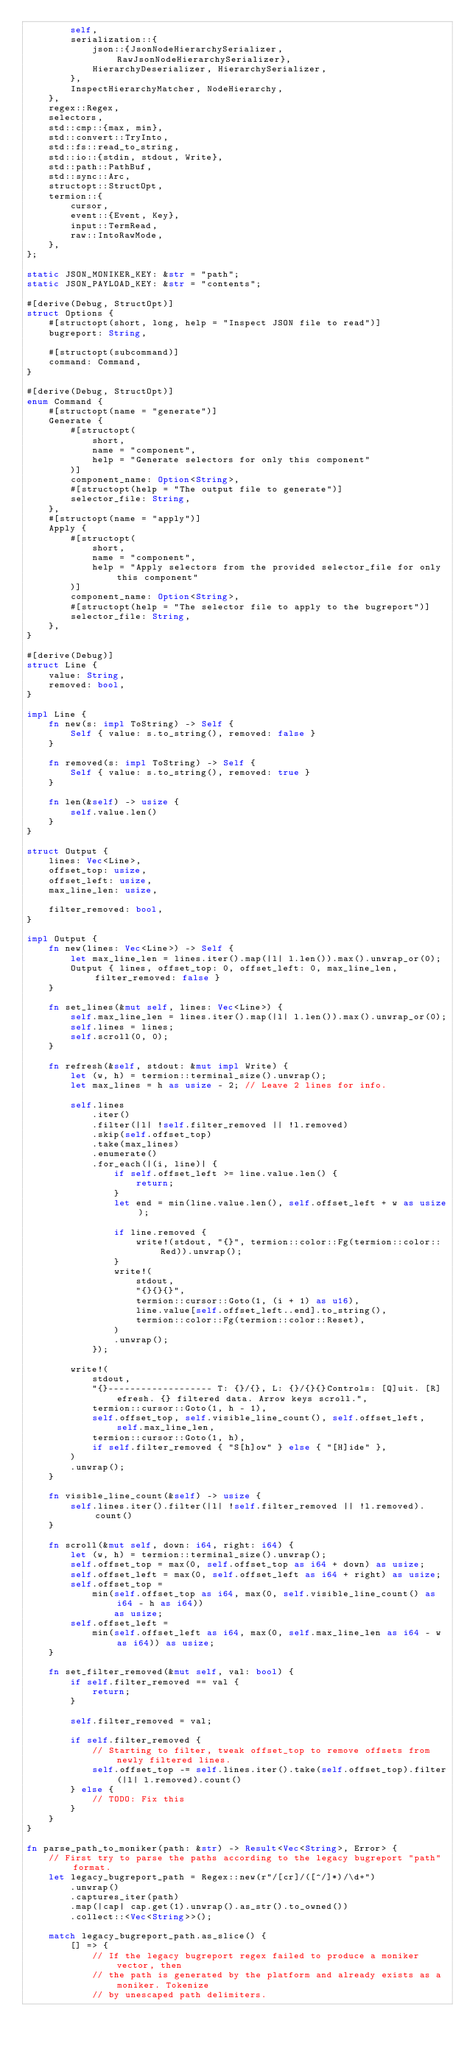<code> <loc_0><loc_0><loc_500><loc_500><_Rust_>        self,
        serialization::{
            json::{JsonNodeHierarchySerializer, RawJsonNodeHierarchySerializer},
            HierarchyDeserializer, HierarchySerializer,
        },
        InspectHierarchyMatcher, NodeHierarchy,
    },
    regex::Regex,
    selectors,
    std::cmp::{max, min},
    std::convert::TryInto,
    std::fs::read_to_string,
    std::io::{stdin, stdout, Write},
    std::path::PathBuf,
    std::sync::Arc,
    structopt::StructOpt,
    termion::{
        cursor,
        event::{Event, Key},
        input::TermRead,
        raw::IntoRawMode,
    },
};

static JSON_MONIKER_KEY: &str = "path";
static JSON_PAYLOAD_KEY: &str = "contents";

#[derive(Debug, StructOpt)]
struct Options {
    #[structopt(short, long, help = "Inspect JSON file to read")]
    bugreport: String,

    #[structopt(subcommand)]
    command: Command,
}

#[derive(Debug, StructOpt)]
enum Command {
    #[structopt(name = "generate")]
    Generate {
        #[structopt(
            short,
            name = "component",
            help = "Generate selectors for only this component"
        )]
        component_name: Option<String>,
        #[structopt(help = "The output file to generate")]
        selector_file: String,
    },
    #[structopt(name = "apply")]
    Apply {
        #[structopt(
            short,
            name = "component",
            help = "Apply selectors from the provided selector_file for only this component"
        )]
        component_name: Option<String>,
        #[structopt(help = "The selector file to apply to the bugreport")]
        selector_file: String,
    },
}

#[derive(Debug)]
struct Line {
    value: String,
    removed: bool,
}

impl Line {
    fn new(s: impl ToString) -> Self {
        Self { value: s.to_string(), removed: false }
    }

    fn removed(s: impl ToString) -> Self {
        Self { value: s.to_string(), removed: true }
    }

    fn len(&self) -> usize {
        self.value.len()
    }
}

struct Output {
    lines: Vec<Line>,
    offset_top: usize,
    offset_left: usize,
    max_line_len: usize,

    filter_removed: bool,
}

impl Output {
    fn new(lines: Vec<Line>) -> Self {
        let max_line_len = lines.iter().map(|l| l.len()).max().unwrap_or(0);
        Output { lines, offset_top: 0, offset_left: 0, max_line_len, filter_removed: false }
    }

    fn set_lines(&mut self, lines: Vec<Line>) {
        self.max_line_len = lines.iter().map(|l| l.len()).max().unwrap_or(0);
        self.lines = lines;
        self.scroll(0, 0);
    }

    fn refresh(&self, stdout: &mut impl Write) {
        let (w, h) = termion::terminal_size().unwrap();
        let max_lines = h as usize - 2; // Leave 2 lines for info.

        self.lines
            .iter()
            .filter(|l| !self.filter_removed || !l.removed)
            .skip(self.offset_top)
            .take(max_lines)
            .enumerate()
            .for_each(|(i, line)| {
                if self.offset_left >= line.value.len() {
                    return;
                }
                let end = min(line.value.len(), self.offset_left + w as usize);

                if line.removed {
                    write!(stdout, "{}", termion::color::Fg(termion::color::Red)).unwrap();
                }
                write!(
                    stdout,
                    "{}{}{}",
                    termion::cursor::Goto(1, (i + 1) as u16),
                    line.value[self.offset_left..end].to_string(),
                    termion::color::Fg(termion::color::Reset),
                )
                .unwrap();
            });

        write!(
            stdout,
            "{}------------------- T: {}/{}, L: {}/{}{}Controls: [Q]uit. [R]efresh. {} filtered data. Arrow keys scroll.",
            termion::cursor::Goto(1, h - 1),
            self.offset_top, self.visible_line_count(), self.offset_left, self.max_line_len,
            termion::cursor::Goto(1, h),
            if self.filter_removed { "S[h]ow" } else { "[H]ide" },
        )
        .unwrap();
    }

    fn visible_line_count(&self) -> usize {
        self.lines.iter().filter(|l| !self.filter_removed || !l.removed).count()
    }

    fn scroll(&mut self, down: i64, right: i64) {
        let (w, h) = termion::terminal_size().unwrap();
        self.offset_top = max(0, self.offset_top as i64 + down) as usize;
        self.offset_left = max(0, self.offset_left as i64 + right) as usize;
        self.offset_top =
            min(self.offset_top as i64, max(0, self.visible_line_count() as i64 - h as i64))
                as usize;
        self.offset_left =
            min(self.offset_left as i64, max(0, self.max_line_len as i64 - w as i64)) as usize;
    }

    fn set_filter_removed(&mut self, val: bool) {
        if self.filter_removed == val {
            return;
        }

        self.filter_removed = val;

        if self.filter_removed {
            // Starting to filter, tweak offset_top to remove offsets from newly filtered lines.
            self.offset_top -= self.lines.iter().take(self.offset_top).filter(|l| l.removed).count()
        } else {
            // TODO: Fix this
        }
    }
}

fn parse_path_to_moniker(path: &str) -> Result<Vec<String>, Error> {
    // First try to parse the paths according to the legacy bugreport "path" format.
    let legacy_bugreport_path = Regex::new(r"/[cr]/([^/]*)/\d+")
        .unwrap()
        .captures_iter(path)
        .map(|cap| cap.get(1).unwrap().as_str().to_owned())
        .collect::<Vec<String>>();

    match legacy_bugreport_path.as_slice() {
        [] => {
            // If the legacy bugreport regex failed to produce a moniker vector, then
            // the path is generated by the platform and already exists as a moniker. Tokenize
            // by unescaped path delimiters.</code> 